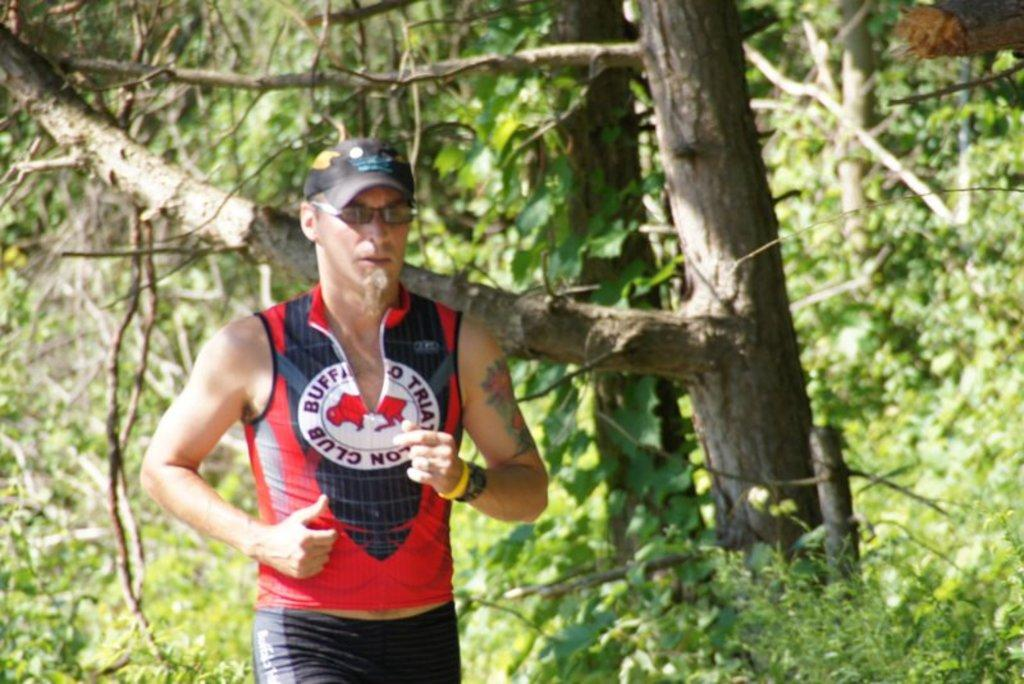<image>
Describe the image concisely. a person running with the word buffalo on their shirt 